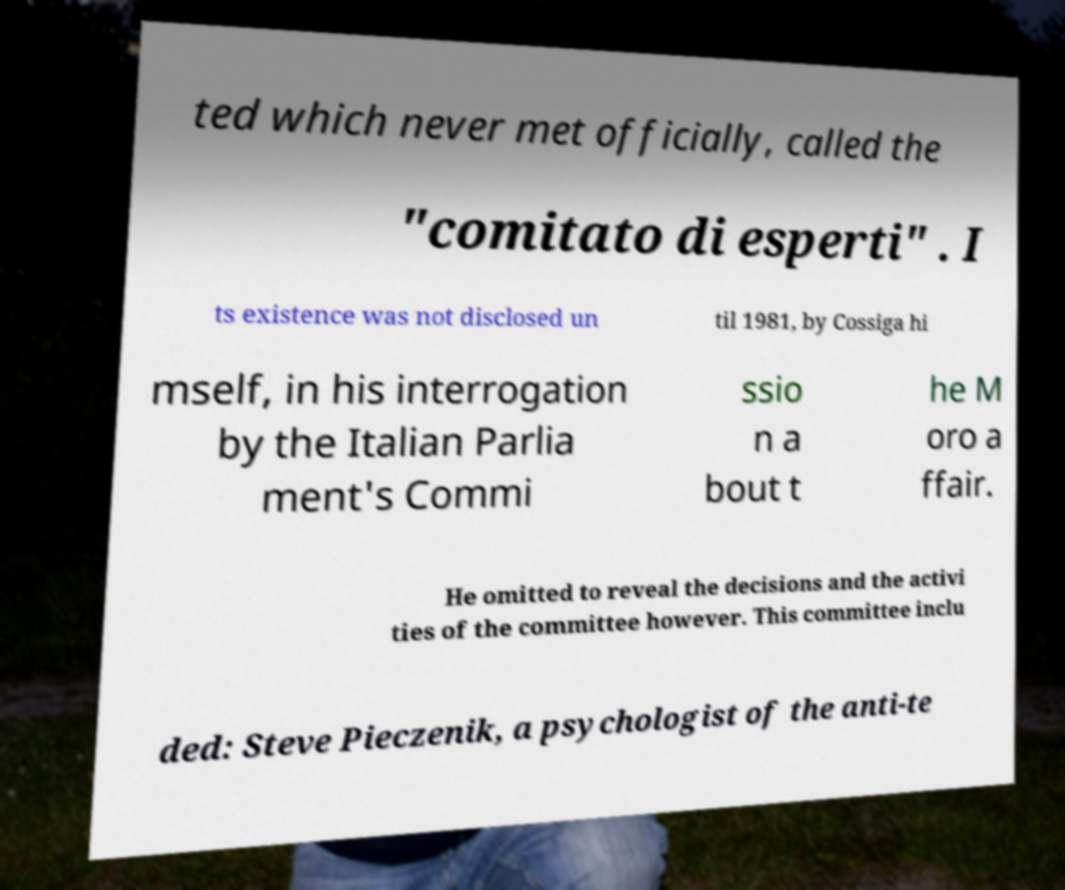Can you read and provide the text displayed in the image?This photo seems to have some interesting text. Can you extract and type it out for me? ted which never met officially, called the "comitato di esperti" . I ts existence was not disclosed un til 1981, by Cossiga hi mself, in his interrogation by the Italian Parlia ment's Commi ssio n a bout t he M oro a ffair. He omitted to reveal the decisions and the activi ties of the committee however. This committee inclu ded: Steve Pieczenik, a psychologist of the anti-te 